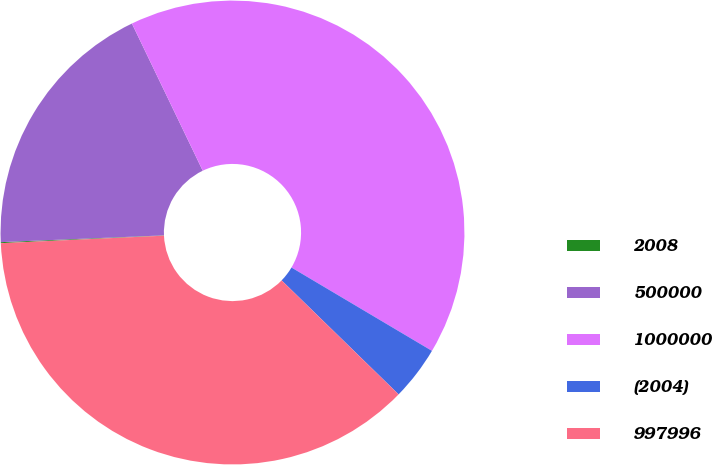Convert chart. <chart><loc_0><loc_0><loc_500><loc_500><pie_chart><fcel>2008<fcel>500000<fcel>1000000<fcel>(2004)<fcel>997996<nl><fcel>0.07%<fcel>18.52%<fcel>40.66%<fcel>3.77%<fcel>36.97%<nl></chart> 